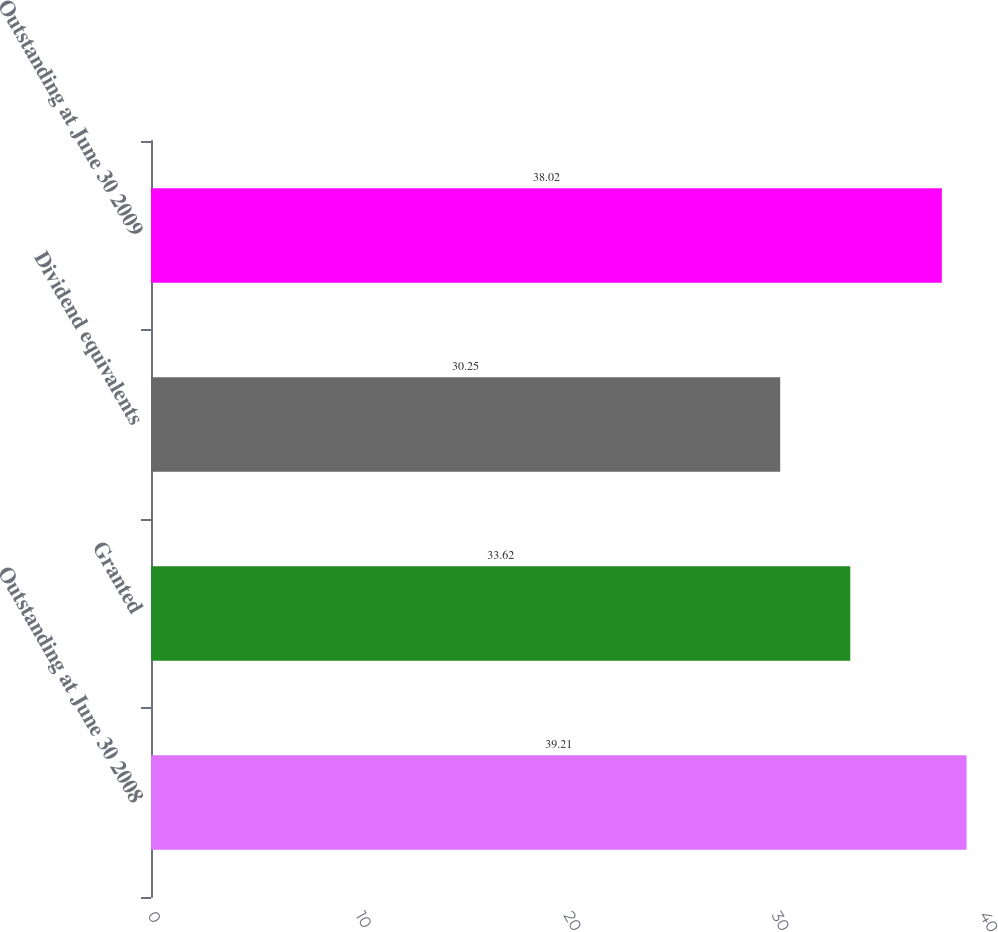<chart> <loc_0><loc_0><loc_500><loc_500><bar_chart><fcel>Outstanding at June 30 2008<fcel>Granted<fcel>Dividend equivalents<fcel>Outstanding at June 30 2009<nl><fcel>39.21<fcel>33.62<fcel>30.25<fcel>38.02<nl></chart> 